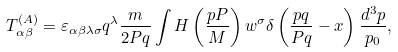Convert formula to latex. <formula><loc_0><loc_0><loc_500><loc_500>T _ { \alpha \beta } ^ { ( A ) } = \varepsilon _ { \alpha \beta \lambda \sigma } q ^ { \lambda } \frac { m } { 2 P q } \int H \left ( \frac { p P } { M } \right ) w ^ { \sigma } \delta \left ( \frac { p q } { P q } - x \right ) \frac { d ^ { 3 } p } { p _ { 0 } } ,</formula> 